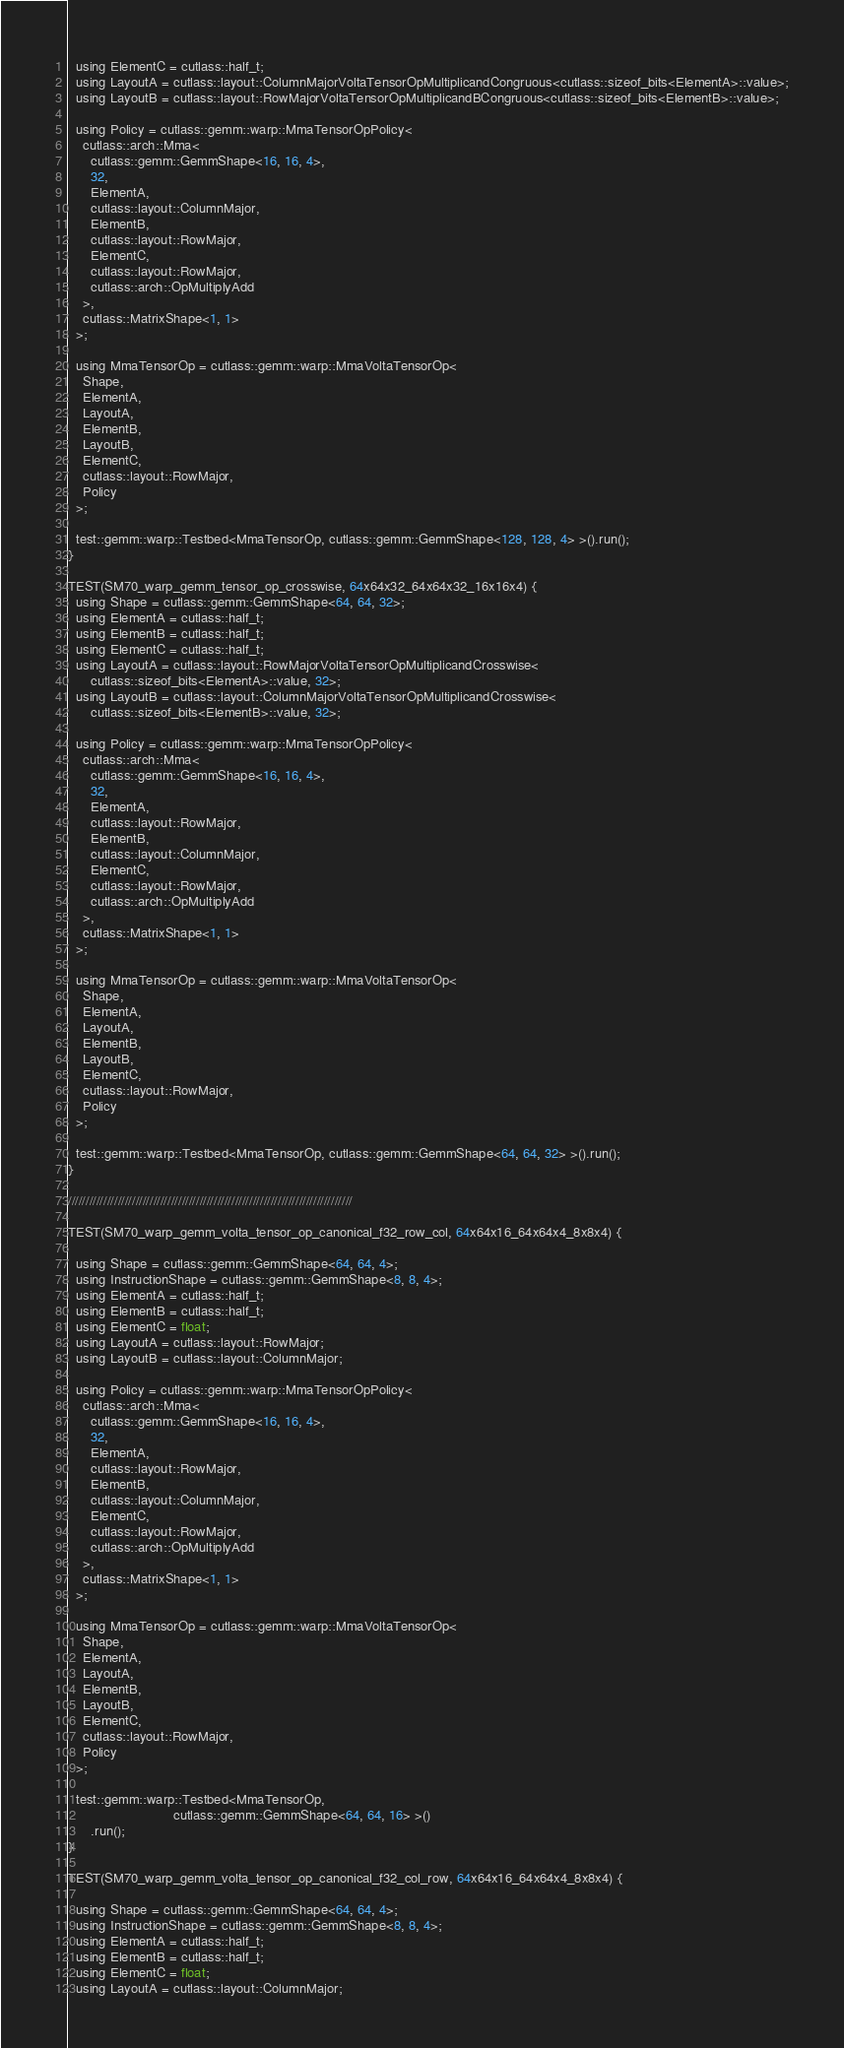<code> <loc_0><loc_0><loc_500><loc_500><_Cuda_>  using ElementC = cutlass::half_t;
  using LayoutA = cutlass::layout::ColumnMajorVoltaTensorOpMultiplicandCongruous<cutlass::sizeof_bits<ElementA>::value>;
  using LayoutB = cutlass::layout::RowMajorVoltaTensorOpMultiplicandBCongruous<cutlass::sizeof_bits<ElementB>::value>;

  using Policy = cutlass::gemm::warp::MmaTensorOpPolicy<
    cutlass::arch::Mma<
      cutlass::gemm::GemmShape<16, 16, 4>,
      32,
      ElementA,
      cutlass::layout::ColumnMajor,
      ElementB,
      cutlass::layout::RowMajor,
      ElementC,
      cutlass::layout::RowMajor,
      cutlass::arch::OpMultiplyAdd
    >,
    cutlass::MatrixShape<1, 1>
  >;

  using MmaTensorOp = cutlass::gemm::warp::MmaVoltaTensorOp<
    Shape,
    ElementA,
    LayoutA,
    ElementB,
    LayoutB,
    ElementC,
    cutlass::layout::RowMajor,
    Policy
  >;

  test::gemm::warp::Testbed<MmaTensorOp, cutlass::gemm::GemmShape<128, 128, 4> >().run();
}

TEST(SM70_warp_gemm_tensor_op_crosswise, 64x64x32_64x64x32_16x16x4) {
  using Shape = cutlass::gemm::GemmShape<64, 64, 32>;
  using ElementA = cutlass::half_t;
  using ElementB = cutlass::half_t;
  using ElementC = cutlass::half_t;
  using LayoutA = cutlass::layout::RowMajorVoltaTensorOpMultiplicandCrosswise<
      cutlass::sizeof_bits<ElementA>::value, 32>;
  using LayoutB = cutlass::layout::ColumnMajorVoltaTensorOpMultiplicandCrosswise<
      cutlass::sizeof_bits<ElementB>::value, 32>;

  using Policy = cutlass::gemm::warp::MmaTensorOpPolicy<
    cutlass::arch::Mma<
      cutlass::gemm::GemmShape<16, 16, 4>,
      32,
      ElementA,
      cutlass::layout::RowMajor,
      ElementB,
      cutlass::layout::ColumnMajor,
      ElementC,
      cutlass::layout::RowMajor,
      cutlass::arch::OpMultiplyAdd
    >,
    cutlass::MatrixShape<1, 1>
  >;

  using MmaTensorOp = cutlass::gemm::warp::MmaVoltaTensorOp<
    Shape,
    ElementA,
    LayoutA,
    ElementB,
    LayoutB,
    ElementC,
    cutlass::layout::RowMajor,
    Policy
  >;

  test::gemm::warp::Testbed<MmaTensorOp, cutlass::gemm::GemmShape<64, 64, 32> >().run();
}

////////////////////////////////////////////////////////////////////////////////

TEST(SM70_warp_gemm_volta_tensor_op_canonical_f32_row_col, 64x64x16_64x64x4_8x8x4) {
  
  using Shape = cutlass::gemm::GemmShape<64, 64, 4>;
  using InstructionShape = cutlass::gemm::GemmShape<8, 8, 4>;
  using ElementA = cutlass::half_t;
  using ElementB = cutlass::half_t;
  using ElementC = float;
  using LayoutA = cutlass::layout::RowMajor;
  using LayoutB = cutlass::layout::ColumnMajor;

  using Policy = cutlass::gemm::warp::MmaTensorOpPolicy<
    cutlass::arch::Mma<
      cutlass::gemm::GemmShape<16, 16, 4>,
      32,
      ElementA,
      cutlass::layout::RowMajor,
      ElementB,
      cutlass::layout::ColumnMajor,
      ElementC,
      cutlass::layout::RowMajor,
      cutlass::arch::OpMultiplyAdd
    >,
    cutlass::MatrixShape<1, 1>
  >;

  using MmaTensorOp = cutlass::gemm::warp::MmaVoltaTensorOp<
    Shape,
    ElementA,
    LayoutA,
    ElementB,
    LayoutB,
    ElementC,
    cutlass::layout::RowMajor,
    Policy
  >;

  test::gemm::warp::Testbed<MmaTensorOp,
                            cutlass::gemm::GemmShape<64, 64, 16> >()
      .run();
}

TEST(SM70_warp_gemm_volta_tensor_op_canonical_f32_col_row, 64x64x16_64x64x4_8x8x4) {
  
  using Shape = cutlass::gemm::GemmShape<64, 64, 4>;
  using InstructionShape = cutlass::gemm::GemmShape<8, 8, 4>;
  using ElementA = cutlass::half_t;
  using ElementB = cutlass::half_t;
  using ElementC = float;
  using LayoutA = cutlass::layout::ColumnMajor;</code> 